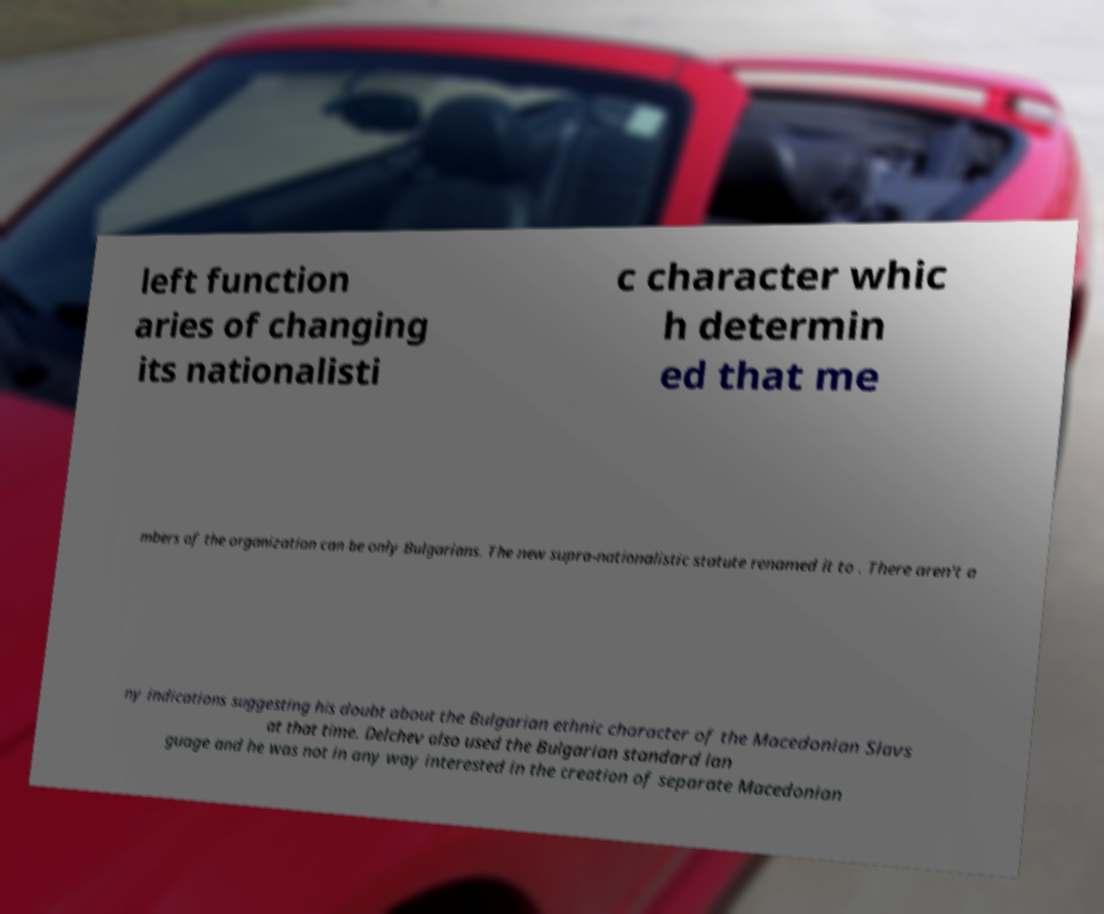I need the written content from this picture converted into text. Can you do that? left function aries of changing its nationalisti c character whic h determin ed that me mbers of the organization can be only Bulgarians. The new supra-nationalistic statute renamed it to . There aren't a ny indications suggesting his doubt about the Bulgarian ethnic character of the Macedonian Slavs at that time. Delchev also used the Bulgarian standard lan guage and he was not in any way interested in the creation of separate Macedonian 